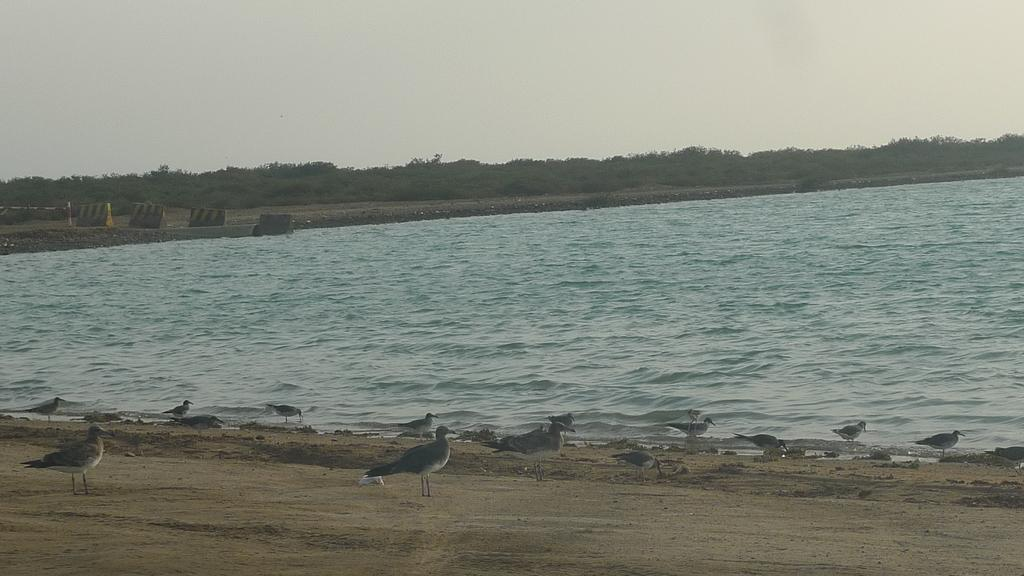What is the main feature of the image? The main feature of the image is water. What can be seen near the water? There are birds on the sand near the water. What other objects are present in the image? There are big stones, a pole, and trees in the image. What is visible in the background of the image? The sky is visible in the image. Where are the ants carrying the ball in the image? There are no ants or balls present in the image. What type of coil is wrapped around the pole in the image? There is no coil present in the image; only a pole is visible. 